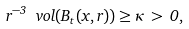<formula> <loc_0><loc_0><loc_500><loc_500>r ^ { - 3 } \ v o l ( B _ { t } ( x , r ) ) \geq \kappa \, > \, 0 ,</formula> 